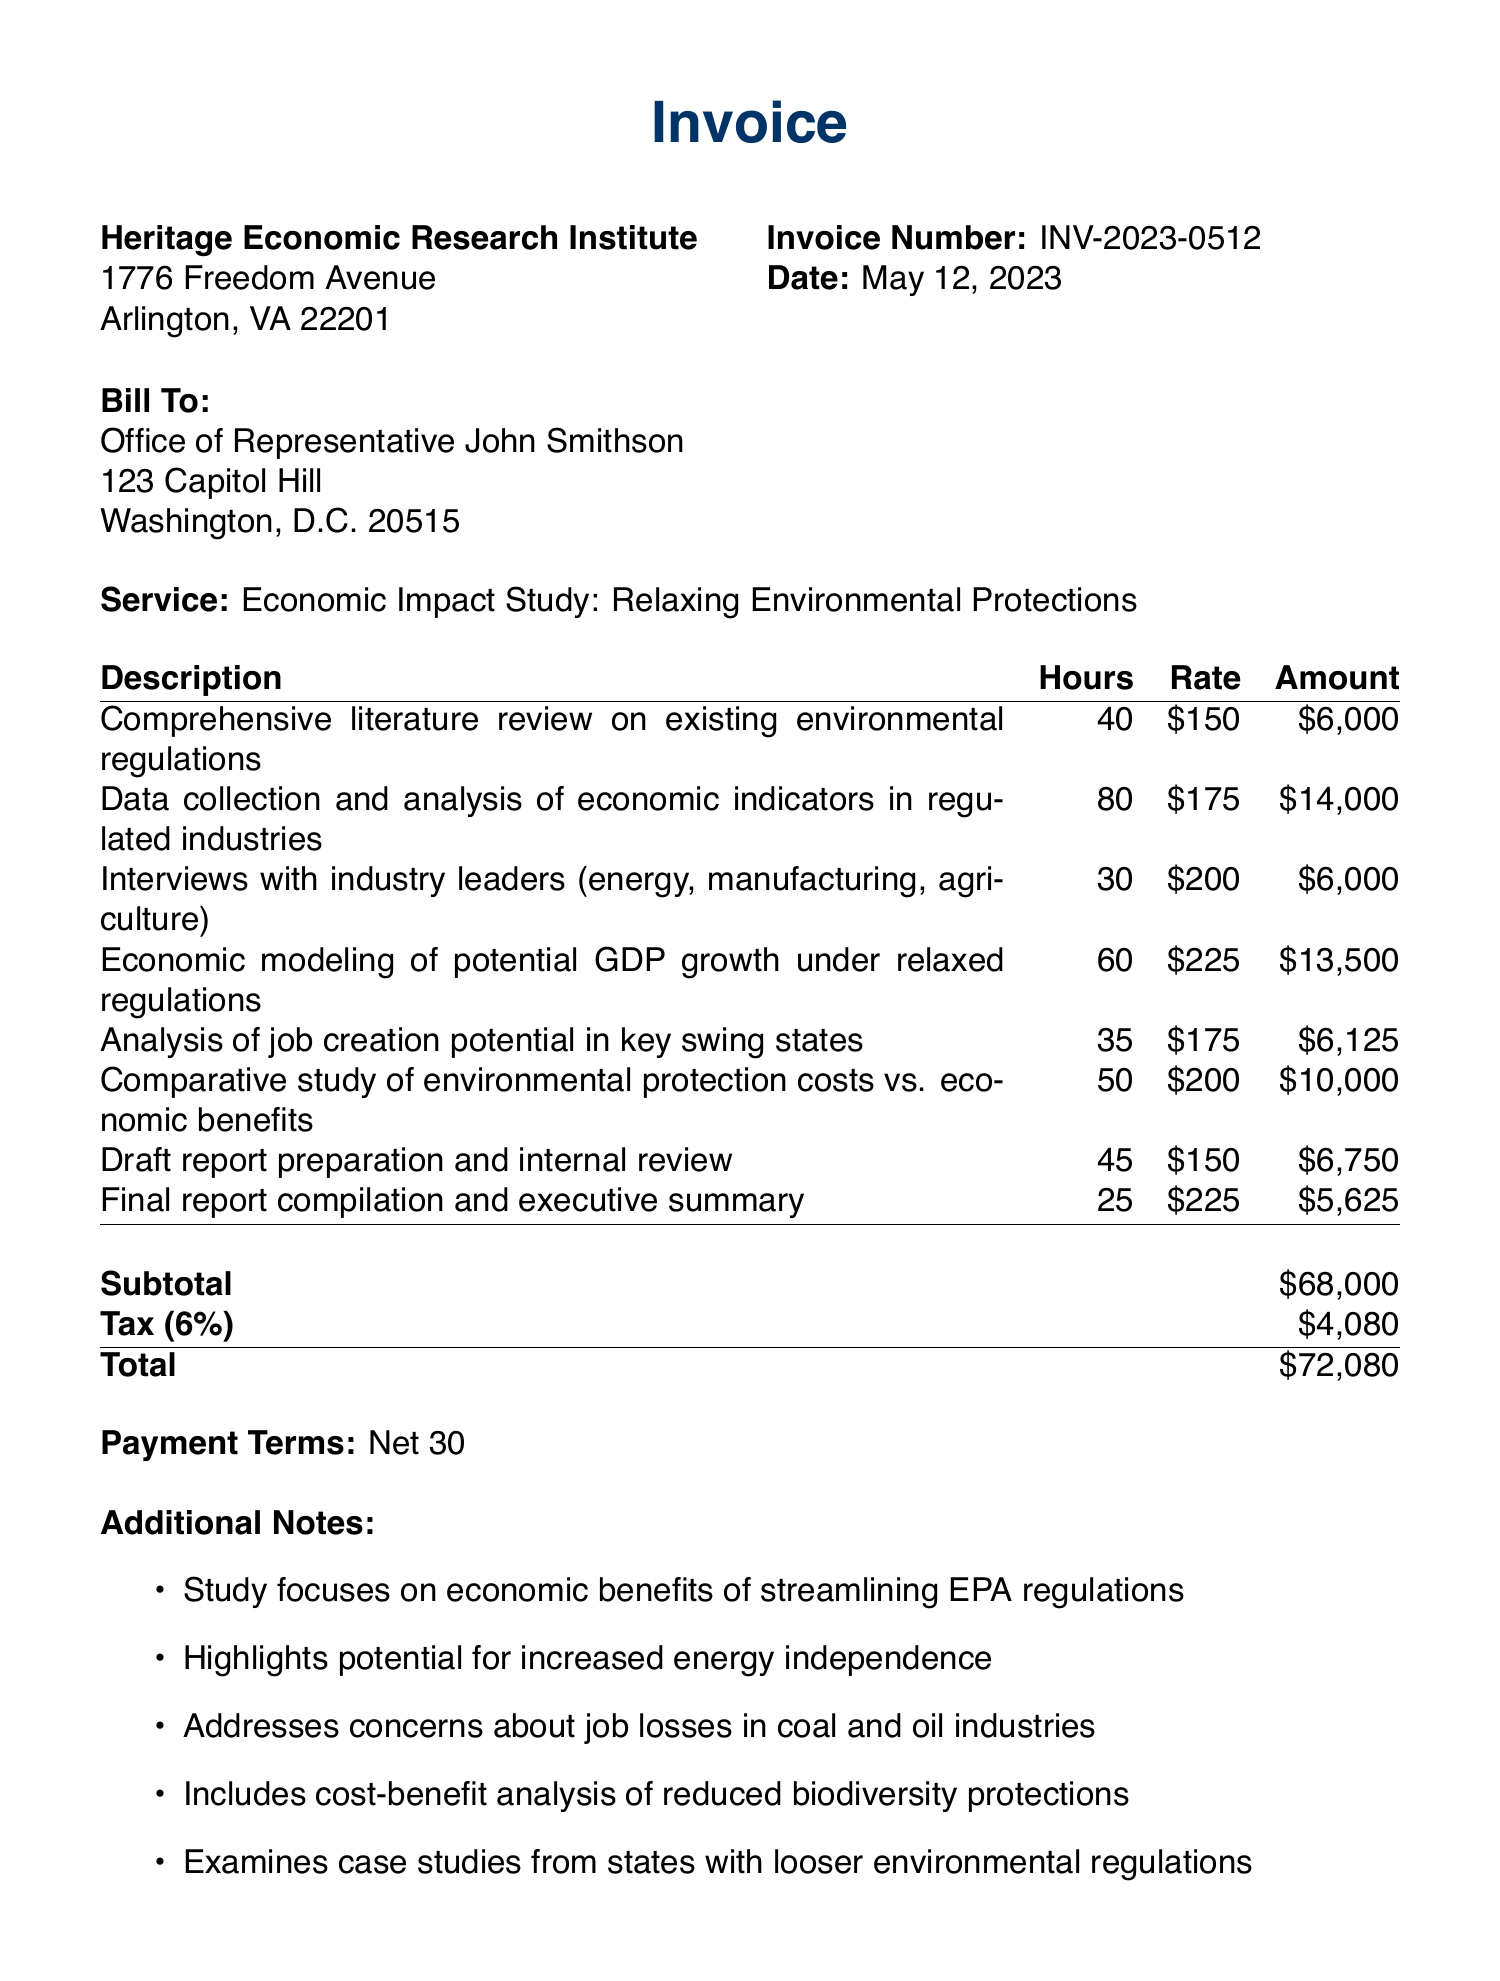What is the invoice number? The invoice number is clearly stated as part of the header of the document, which is INV-2023-0512.
Answer: INV-2023-0512 What is the date of the invoice? The date is provided in the header section of the invoice, listed as May 12, 2023.
Answer: May 12, 2023 Who is the client for this invoice? The client name is specified in the bill-to section, which is Office of Representative John Smithson.
Answer: Office of Representative John Smithson What is the total amount due? The total amount is provided in the financial summary at the bottom of the document, which is $72,080.
Answer: $72,080 How many hours were spent on economic modeling? The hours for economic modeling are listed in the line items as 60 hours.
Answer: 60 What is the tax rate applied to the invoice? The tax rate is mentioned in the financial summary, which is 6%.
Answer: 6% What service does this invoice pertain to? The service is indicated in the document as Economic Impact Study: Relaxing Environmental Protections.
Answer: Economic Impact Study: Relaxing Environmental Protections What is the payment term specified in the invoice? The payment terms are described at the bottom of the invoice as Net 30.
Answer: Net 30 What is one of the additional notes related to this study? The notes section includes multiple points, one of which is that the study includes a cost-benefit analysis of reduced biodiversity protections.
Answer: Includes cost-benefit analysis of reduced biodiversity protections 